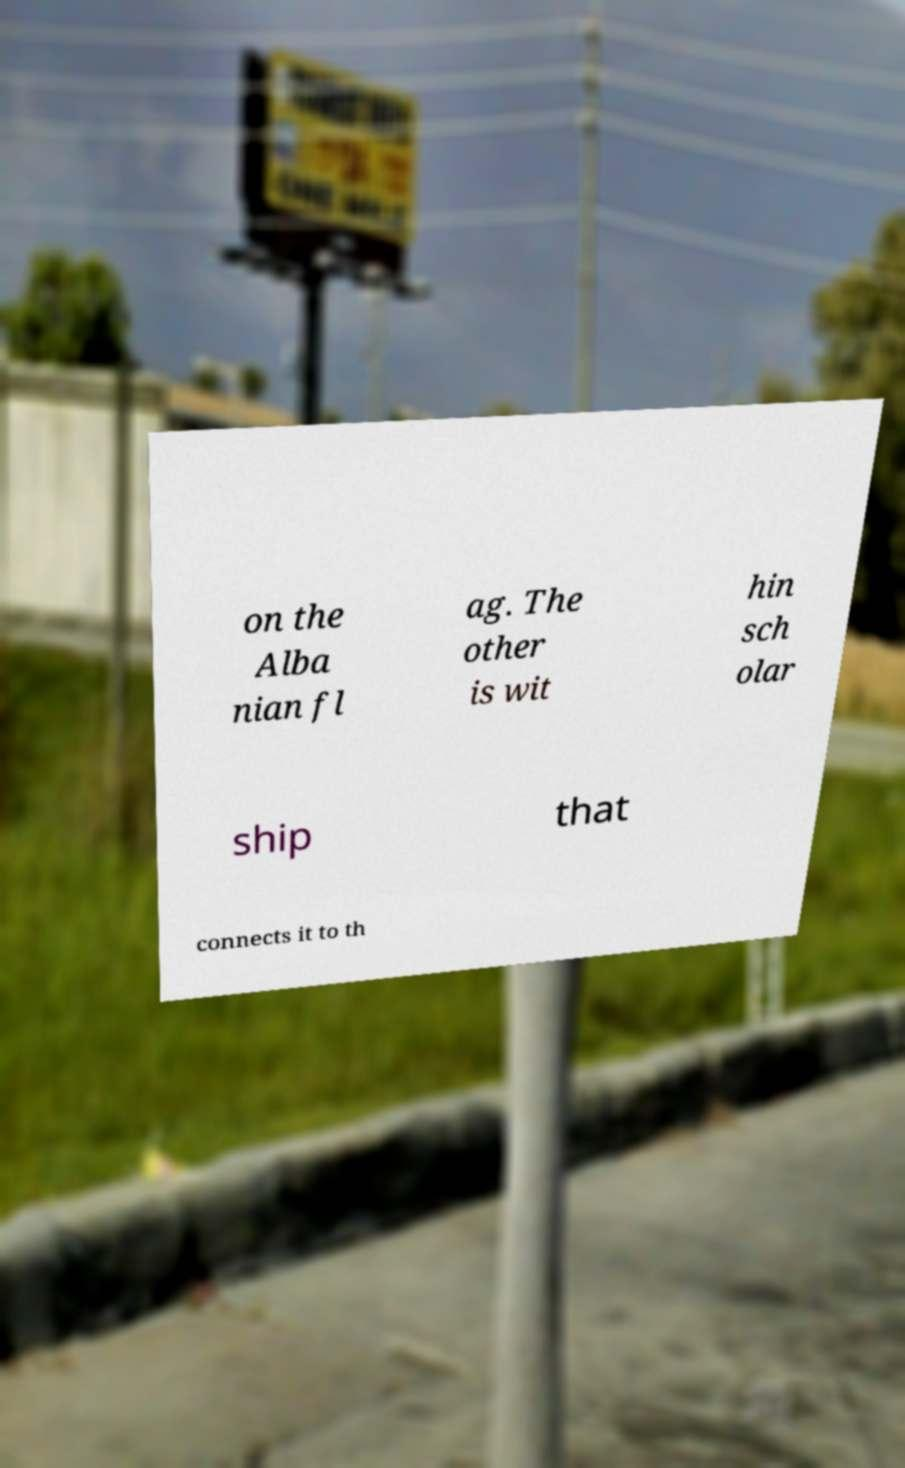Could you assist in decoding the text presented in this image and type it out clearly? on the Alba nian fl ag. The other is wit hin sch olar ship that connects it to th 